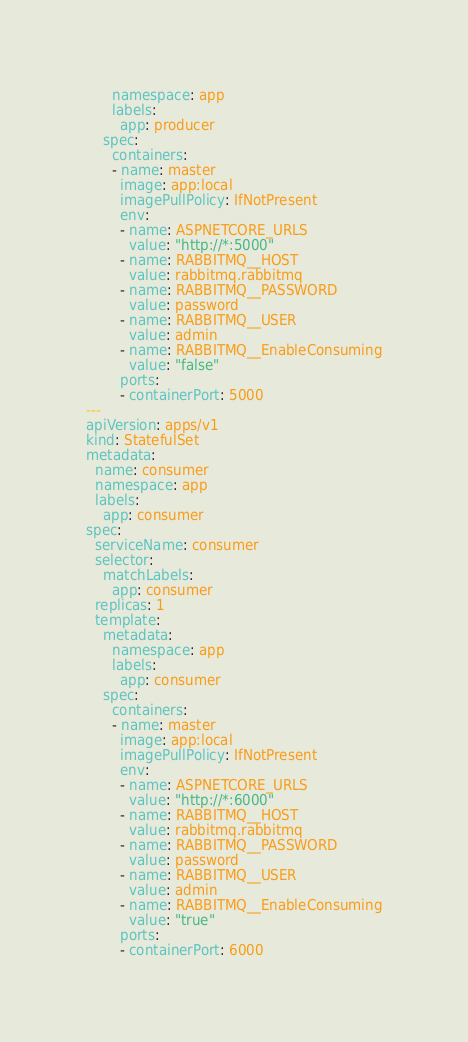<code> <loc_0><loc_0><loc_500><loc_500><_YAML_>      namespace: app
      labels:
        app: producer
    spec:
      containers:
      - name: master
        image: app:local
        imagePullPolicy: IfNotPresent
        env:
        - name: ASPNETCORE_URLS
          value: "http://*:5000"
        - name: RABBITMQ__HOST
          value: rabbitmq.rabbitmq
        - name: RABBITMQ__PASSWORD
          value: password
        - name: RABBITMQ__USER
          value: admin
        - name: RABBITMQ__EnableConsuming
          value: "false"
        ports:
        - containerPort: 5000
---
apiVersion: apps/v1
kind: StatefulSet
metadata:
  name: consumer
  namespace: app
  labels:
    app: consumer
spec:
  serviceName: consumer
  selector:
    matchLabels:
      app: consumer
  replicas: 1
  template:
    metadata:
      namespace: app
      labels:
        app: consumer
    spec:
      containers:
      - name: master
        image: app:local
        imagePullPolicy: IfNotPresent
        env:
        - name: ASPNETCORE_URLS
          value: "http://*:6000"
        - name: RABBITMQ__HOST
          value: rabbitmq.rabbitmq
        - name: RABBITMQ__PASSWORD
          value: password
        - name: RABBITMQ__USER
          value: admin
        - name: RABBITMQ__EnableConsuming
          value: "true"
        ports:
        - containerPort: 6000
</code> 